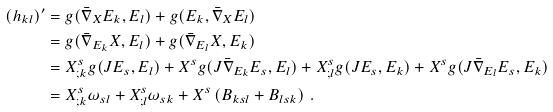Convert formula to latex. <formula><loc_0><loc_0><loc_500><loc_500>( h _ { k l } ) ^ { \prime } & = g ( \bar { \nabla } _ { X } E _ { k } , E _ { l } ) + g ( E _ { k } , \bar { \nabla } _ { X } E _ { l } ) \\ & = g ( \bar { \nabla } _ { E _ { k } } X , E _ { l } ) + g ( \bar { \nabla } _ { E _ { l } } X , E _ { k } ) \\ & = X ^ { s } _ { ; k } g ( J E _ { s } , E _ { l } ) + X ^ { s } g ( J \bar { \nabla } _ { E _ { k } } E _ { s } , E _ { l } ) + X ^ { s } _ { ; l } g ( J E _ { s } , E _ { k } ) + X ^ { s } g ( J \bar { \nabla } _ { E _ { l } } E _ { s } , E _ { k } ) \\ & = X ^ { s } _ { ; k } \omega _ { s l } + X ^ { s } _ { ; l } \omega _ { s k } + X ^ { s } \left ( B _ { k s l } + B _ { l s k } \right ) \, .</formula> 